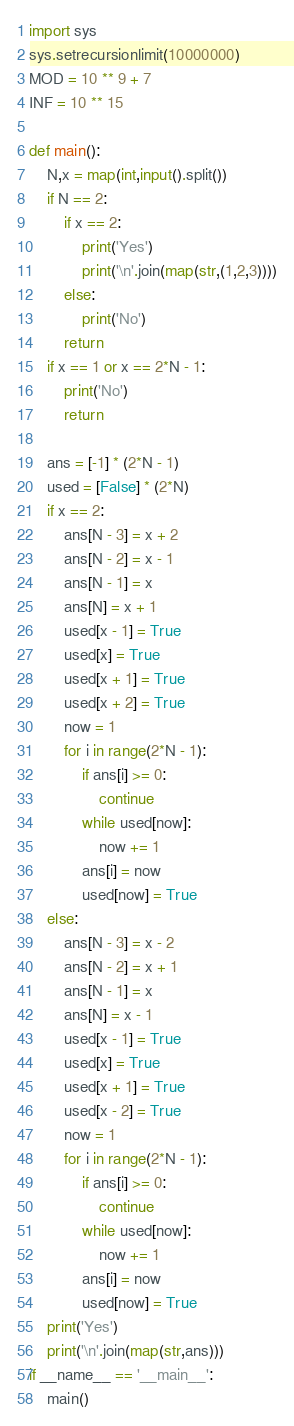<code> <loc_0><loc_0><loc_500><loc_500><_Python_>import sys
sys.setrecursionlimit(10000000)
MOD = 10 ** 9 + 7
INF = 10 ** 15

def main():
    N,x = map(int,input().split())
    if N == 2:
        if x == 2:
            print('Yes')
            print('\n'.join(map(str,(1,2,3))))
        else:
            print('No')
        return
    if x == 1 or x == 2*N - 1:
        print('No')
        return

    ans = [-1] * (2*N - 1)
    used = [False] * (2*N)
    if x == 2:
        ans[N - 3] = x + 2
        ans[N - 2] = x - 1
        ans[N - 1] = x
        ans[N] = x + 1
        used[x - 1] = True
        used[x] = True
        used[x + 1] = True
        used[x + 2] = True
        now = 1
        for i in range(2*N - 1):
            if ans[i] >= 0:
                continue
            while used[now]:
                now += 1
            ans[i] = now
            used[now] = True
    else:
        ans[N - 3] = x - 2
        ans[N - 2] = x + 1
        ans[N - 1] = x
        ans[N] = x - 1
        used[x - 1] = True
        used[x] = True
        used[x + 1] = True
        used[x - 2] = True
        now = 1
        for i in range(2*N - 1):
            if ans[i] >= 0:
                continue
            while used[now]:
                now += 1
            ans[i] = now
            used[now] = True
    print('Yes')
    print('\n'.join(map(str,ans)))
if __name__ == '__main__':
    main()</code> 